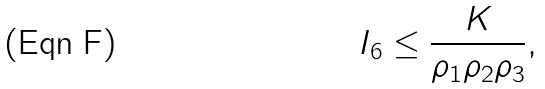<formula> <loc_0><loc_0><loc_500><loc_500>I _ { 6 } \leq \frac { K } { \rho _ { 1 } \rho _ { 2 } \rho _ { 3 } } ,</formula> 